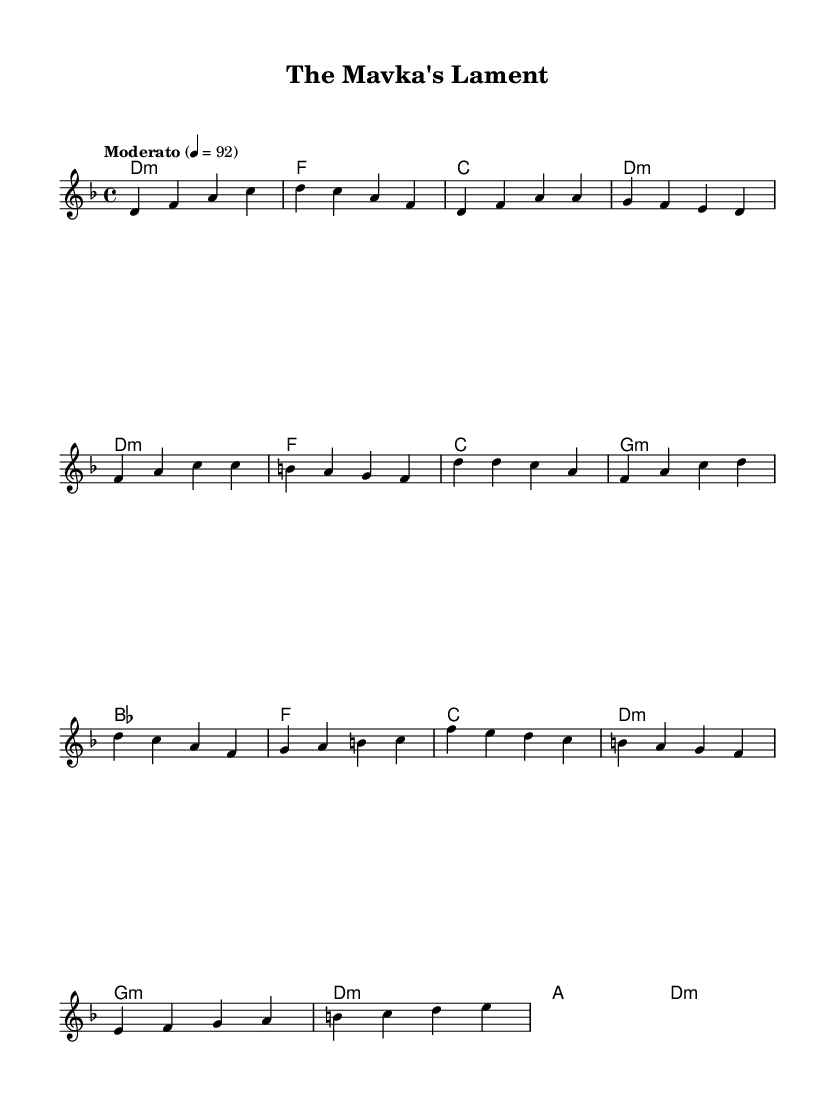What is the key signature of this music? The key signature is D minor, which has one flat (B♭). This can be determined from the presence of the flat symbol in the key signature section at the beginning of the sheet music.
Answer: D minor What is the time signature of this music? The time signature is 4/4, which indicates that there are four beats per measure. This is indicated at the beginning of the sheet music next to the key signature.
Answer: 4/4 What tempo is indicated for this piece? The indicated tempo is "Moderato" at 92 beats per minute. This is specified in the tempo marking located at the start of the musical score.
Answer: Moderato 92 How many measures are in the chorus section? The chorus section consists of four measures. By counting the groupings of notes in the chorus part of the melody line, we identify four measures.
Answer: 4 What type of chords are used in the bridge? The chords in the bridge section include G minor and D minor. By examining the chord symbols written above the melody in that section, we identify these specific chords.
Answer: G minor, D minor What is the primary lyrical theme suggested by the title? The title "The Mavka's Lament" suggests a theme related to sorrow or loss, possibly rooted in Ukrainian folklore. The word "lament" indicates an expression of grief or mourning.
Answer: Sorrow What is the last chord of the piece? The last chord of the piece is D minor. This can be confirmed by looking at the harmony section of the bridge, where the progression concludes with D minor.
Answer: D minor 